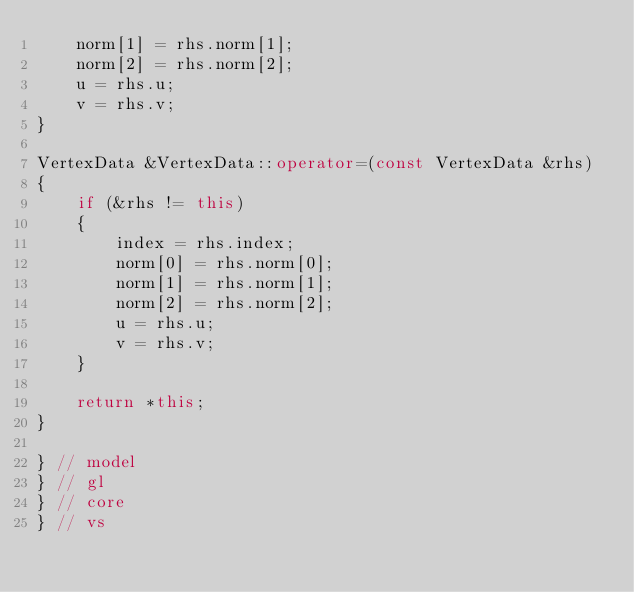<code> <loc_0><loc_0><loc_500><loc_500><_C++_>	norm[1] = rhs.norm[1];
	norm[2] = rhs.norm[2];
	u = rhs.u;
	v = rhs.v;
}

VertexData &VertexData::operator=(const VertexData &rhs)
{
	if (&rhs != this)
	{
		index = rhs.index;
		norm[0] = rhs.norm[0];
		norm[1] = rhs.norm[1];
		norm[2] = rhs.norm[2];
		u = rhs.u;
		v = rhs.v;
	}

	return *this;
}

} // model
} // gl
} // core
} // vs
</code> 